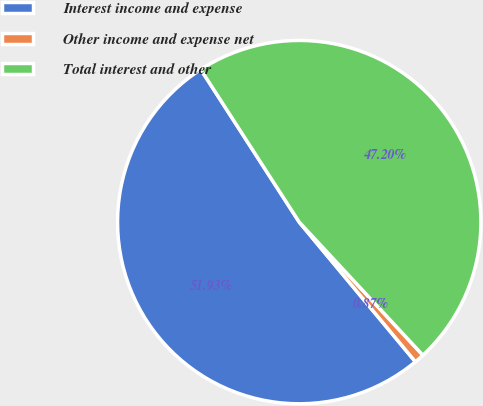Convert chart to OTSL. <chart><loc_0><loc_0><loc_500><loc_500><pie_chart><fcel>Interest income and expense<fcel>Other income and expense net<fcel>Total interest and other<nl><fcel>51.92%<fcel>0.87%<fcel>47.2%<nl></chart> 